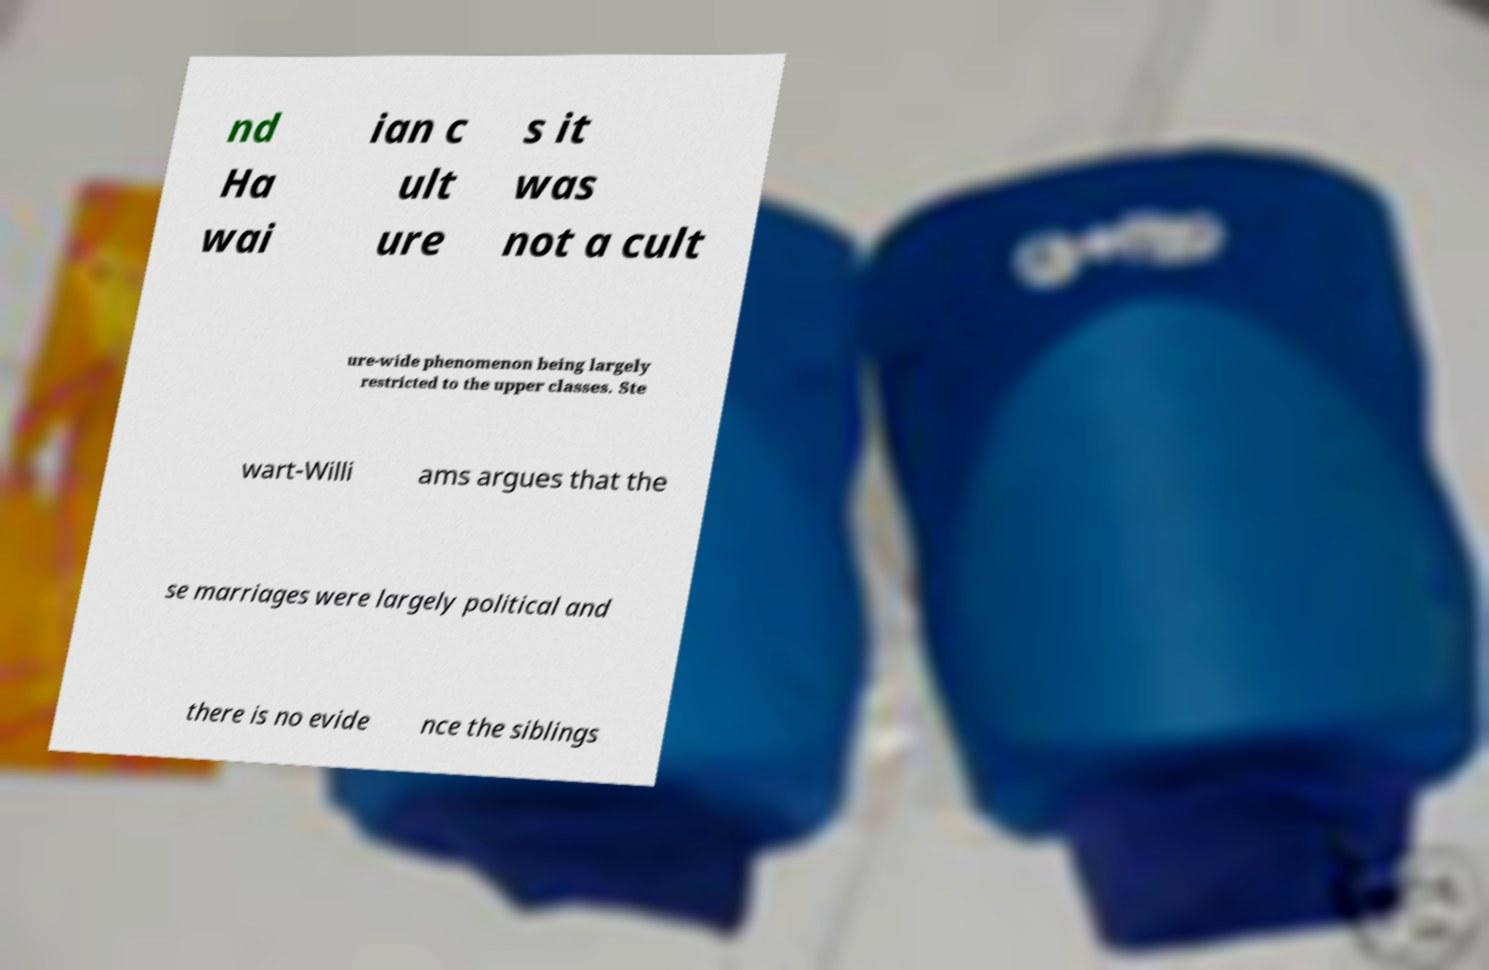Can you read and provide the text displayed in the image?This photo seems to have some interesting text. Can you extract and type it out for me? nd Ha wai ian c ult ure s it was not a cult ure-wide phenomenon being largely restricted to the upper classes. Ste wart-Willi ams argues that the se marriages were largely political and there is no evide nce the siblings 